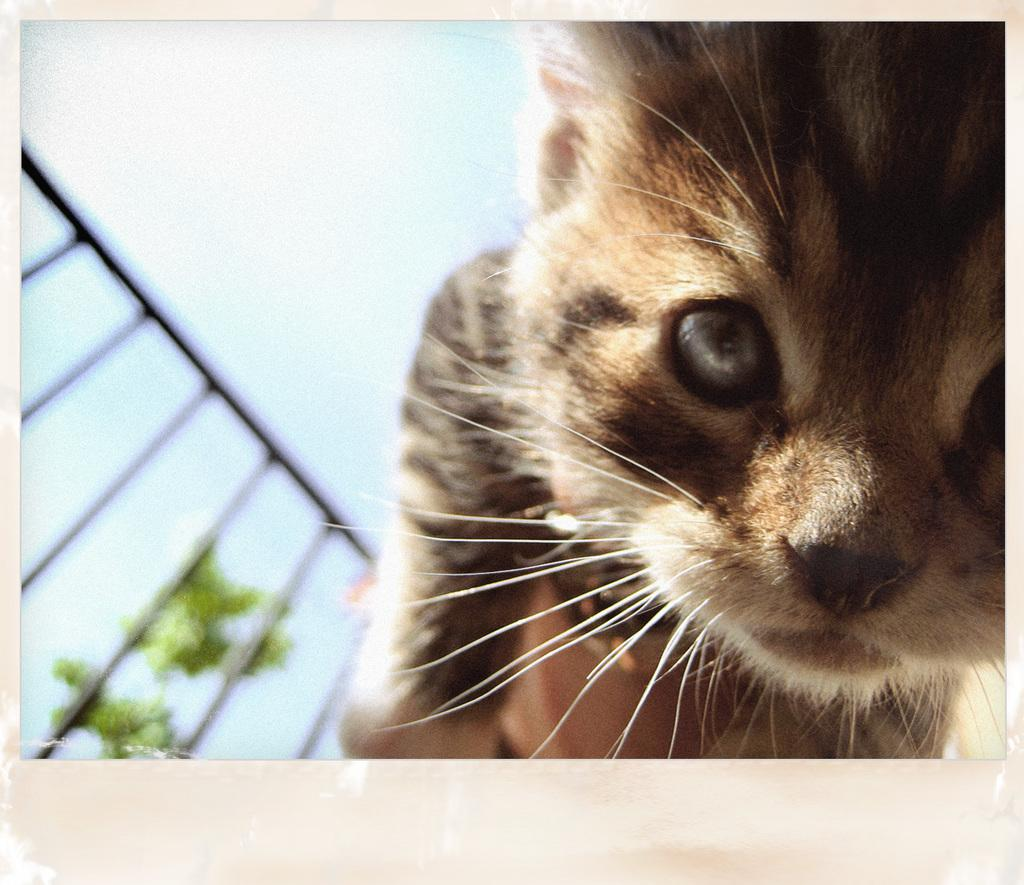What is the main subject of the image? There is a picture of a cat in the image. What can be seen in the background of the image? The sky is visible in the image. Where is the railing located in the image? The railing is in the bottom left of the image. What type of vegetation is present behind the railing? Leaves are present behind the railing. What day of the week is shown on the calendar in the image? There is no calendar present in the image. What type of work is the laborer performing in the image? There is no laborer present in the image. 